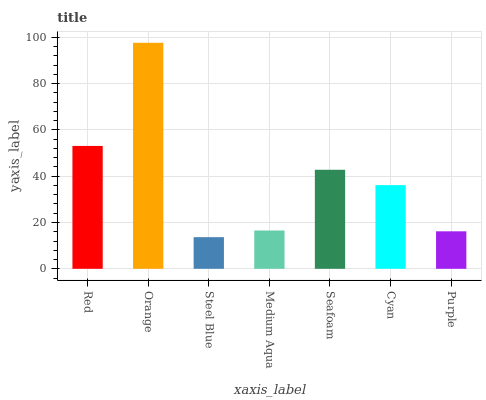Is Steel Blue the minimum?
Answer yes or no. Yes. Is Orange the maximum?
Answer yes or no. Yes. Is Orange the minimum?
Answer yes or no. No. Is Steel Blue the maximum?
Answer yes or no. No. Is Orange greater than Steel Blue?
Answer yes or no. Yes. Is Steel Blue less than Orange?
Answer yes or no. Yes. Is Steel Blue greater than Orange?
Answer yes or no. No. Is Orange less than Steel Blue?
Answer yes or no. No. Is Cyan the high median?
Answer yes or no. Yes. Is Cyan the low median?
Answer yes or no. Yes. Is Seafoam the high median?
Answer yes or no. No. Is Seafoam the low median?
Answer yes or no. No. 